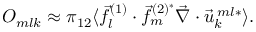<formula> <loc_0><loc_0><loc_500><loc_500>O _ { m l k } \approx \pi _ { 1 2 } \langle \vec { f } _ { l } ^ { ( 1 ) } \cdot \vec { f } _ { m } ^ { ( 2 ) ^ { * } } \vec { \nabla } \cdot \vec { u } _ { k } ^ { \, m l * } \rangle .</formula> 